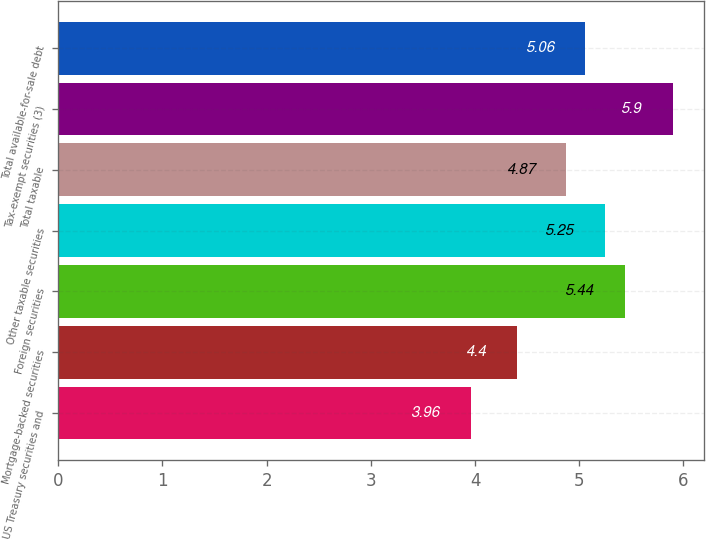Convert chart to OTSL. <chart><loc_0><loc_0><loc_500><loc_500><bar_chart><fcel>US Treasury securities and<fcel>Mortgage-backed securities<fcel>Foreign securities<fcel>Other taxable securities<fcel>Total taxable<fcel>Tax-exempt securities (3)<fcel>Total available-for-sale debt<nl><fcel>3.96<fcel>4.4<fcel>5.44<fcel>5.25<fcel>4.87<fcel>5.9<fcel>5.06<nl></chart> 